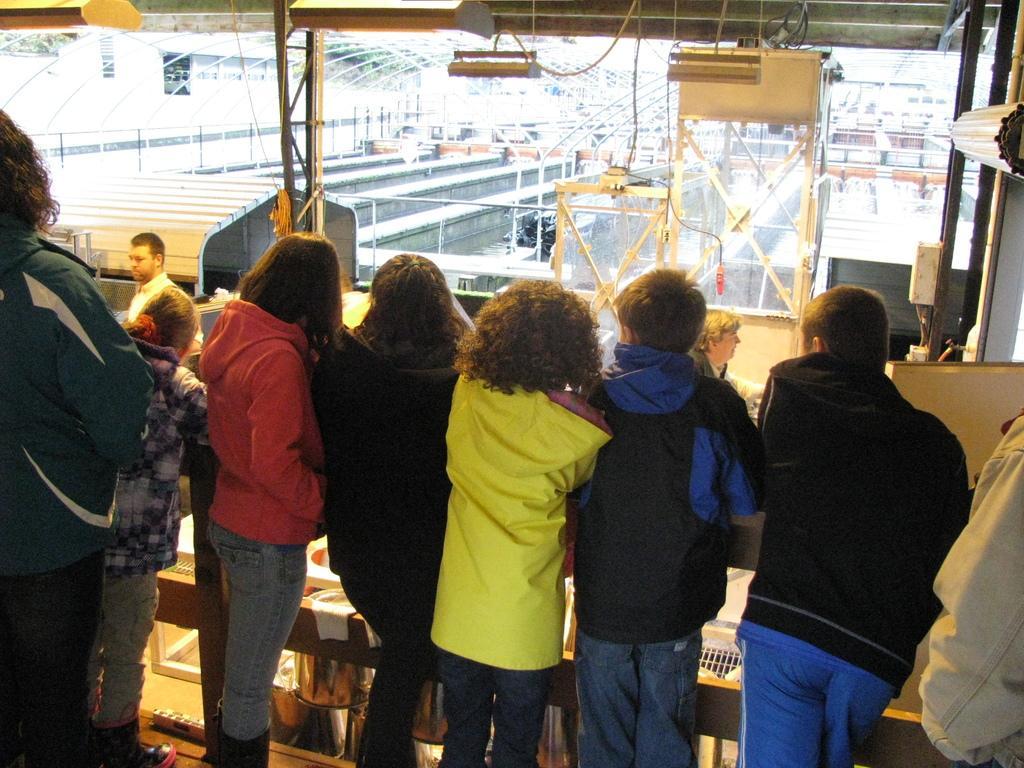Please provide a concise description of this image. In this image in the front there are persons standing. In the background there are objects which are yellow and white in colour and there are stands and there are poles. 